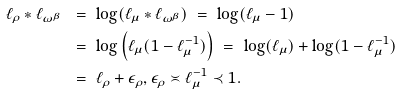<formula> <loc_0><loc_0><loc_500><loc_500>\ell _ { \rho } * \ell _ { \omega ^ { \beta } } \ & = \ \log ( \ell _ { \mu } * \ell _ { \omega ^ { \beta } } ) \ = \ \log ( \ell _ { \mu } - 1 ) \\ & = \ \log \left ( \ell _ { \mu } ( 1 - \ell _ { \mu } ^ { - 1 } ) \right ) \ = \ \log ( \ell _ { \mu } ) + \log ( 1 - \ell _ { \mu } ^ { - 1 } ) \\ & = \ \ell _ { \rho } + \epsilon _ { \rho } , \epsilon _ { \rho } \asymp \ell _ { \mu } ^ { - 1 } \prec 1 .</formula> 